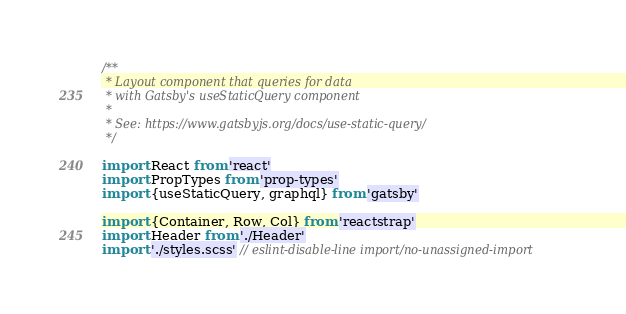<code> <loc_0><loc_0><loc_500><loc_500><_JavaScript_>/**
 * Layout component that queries for data
 * with Gatsby's useStaticQuery component
 *
 * See: https://www.gatsbyjs.org/docs/use-static-query/
 */

import React from 'react'
import PropTypes from 'prop-types'
import {useStaticQuery, graphql} from 'gatsby'

import {Container, Row, Col} from 'reactstrap'
import Header from './Header'
import './styles.scss' // eslint-disable-line import/no-unassigned-import</code> 